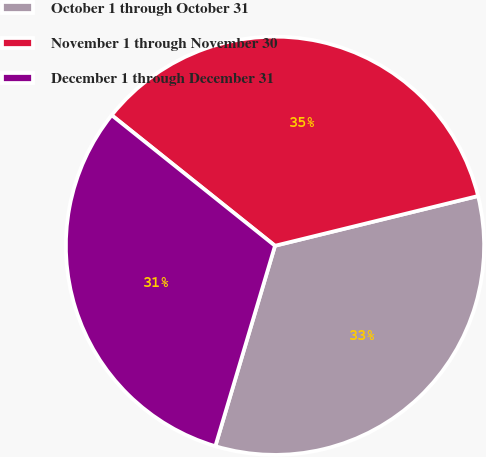<chart> <loc_0><loc_0><loc_500><loc_500><pie_chart><fcel>October 1 through October 31<fcel>November 1 through November 30<fcel>December 1 through December 31<nl><fcel>33.43%<fcel>35.44%<fcel>31.13%<nl></chart> 